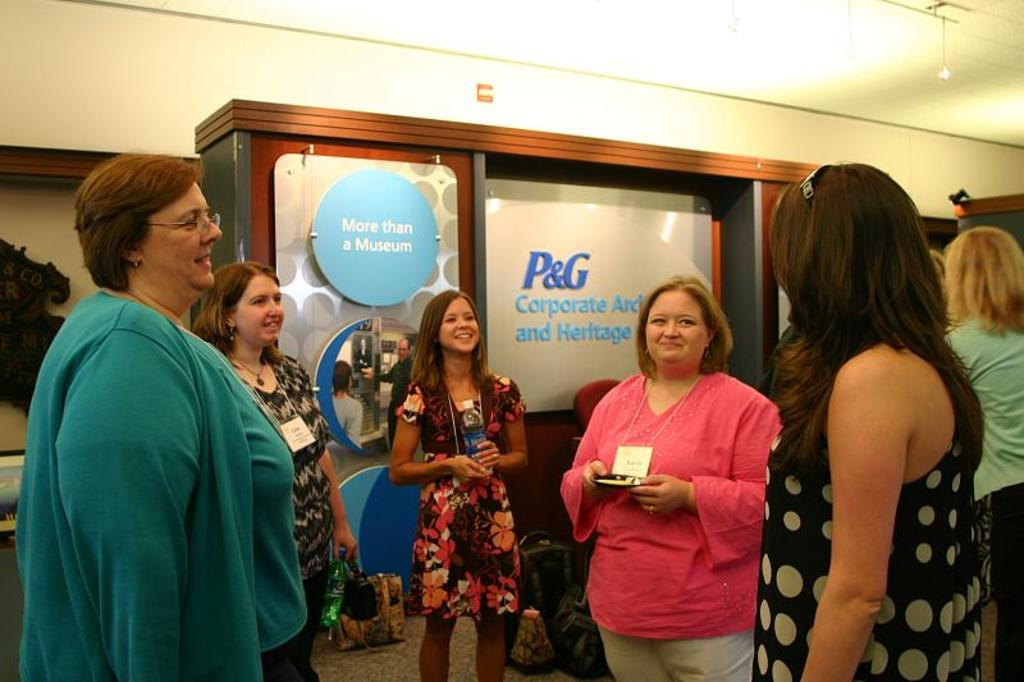How many people are in the image? There is a group of people in the image. What is the position of the people in the image? The people are standing on the floor. What can be seen in the background of the image? There are boards, a wall, and some objects visible in the background of the image. How many children are playing in the house in the image? There is no house or children present in the image; it features a group of people standing on the floor with a background containing boards, a wall, and other objects. 